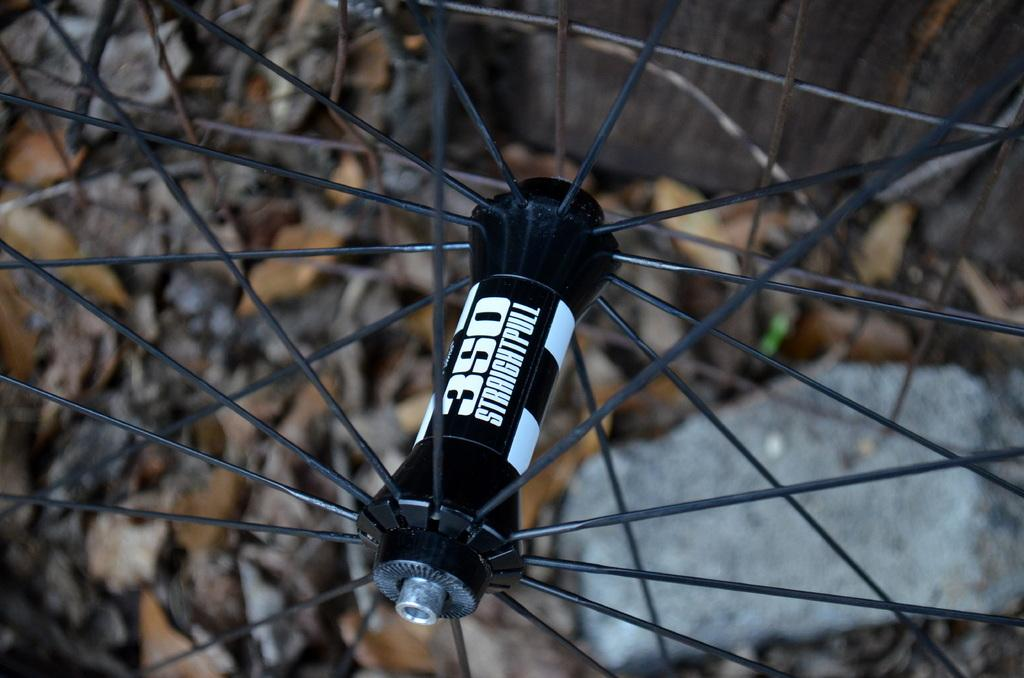What is the main object in the image? There is a wheel in the image. What type of cheese is being held by the hands in the image? There are no hands or cheese present in the image; it only features a wheel. 